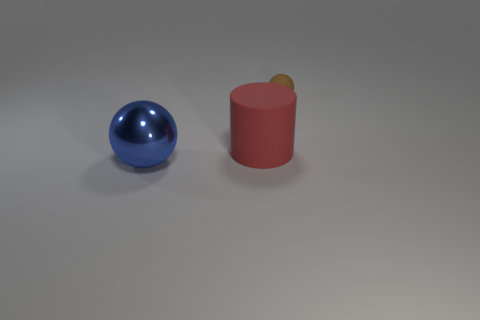What time of day does the lighting in this image suggest? The lighting in this image doesn't necessarily reflect a natural environment, so it's difficult to deduce an exact time of day. However, the soft shadows and the general neutral quality of the light suggest an indoor setting, possibly illuminated by artificial studio lighting typically used in professional photography or rendering environments. 